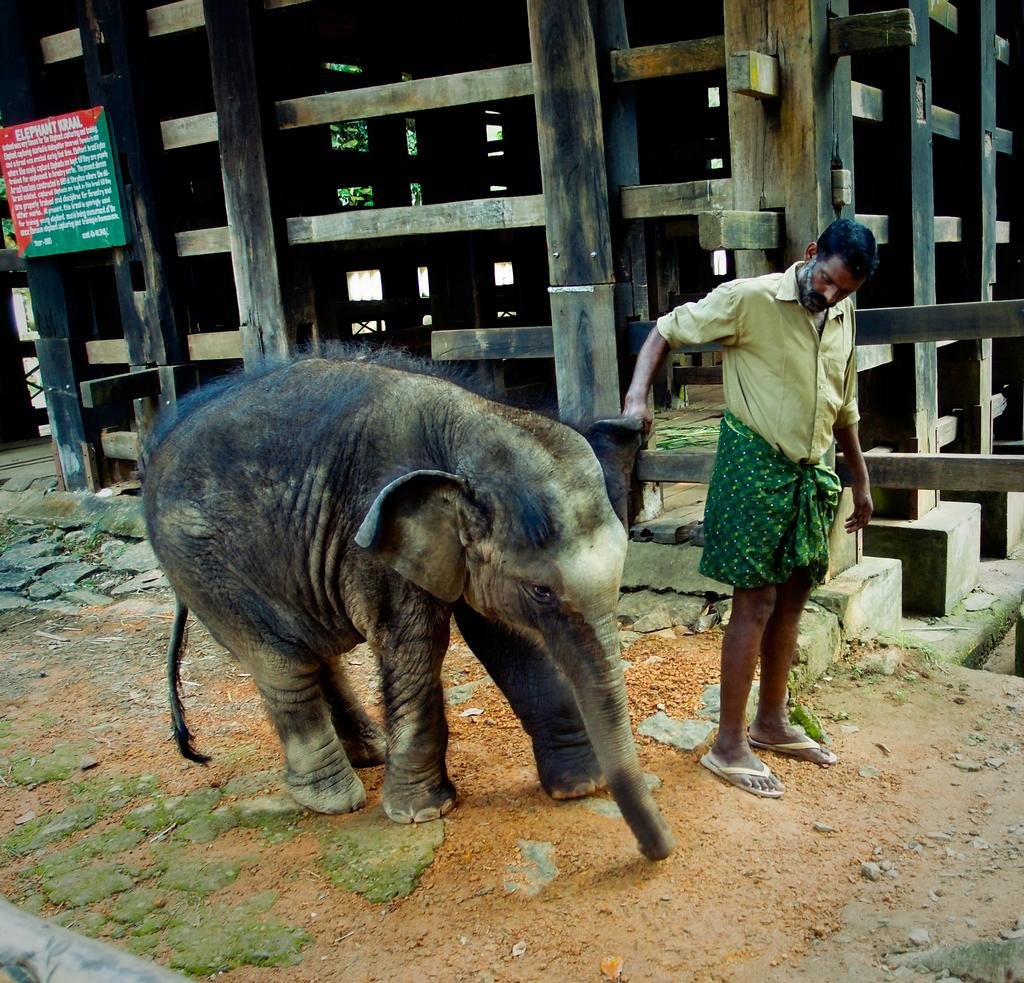What animal is present in the picture? There is an elephant in the picture. Who else is present in the picture besides the elephant? There is a man standing in the picture. What object can be seen in the picture that is used for displaying information or advertisements? There is a board in the picture. What structure is present in the picture that is used to house the elephant? There is an elephant wooden cage in the picture. What type of plant can be seen in the picture? There is a tree in the picture. What type of umbrella is the monkey holding in the picture? There is no monkey or umbrella present in the picture. 